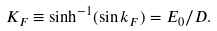<formula> <loc_0><loc_0><loc_500><loc_500>K _ { F } \equiv \sinh ^ { - 1 } ( \sin k _ { F } ) = E _ { 0 } / D .</formula> 